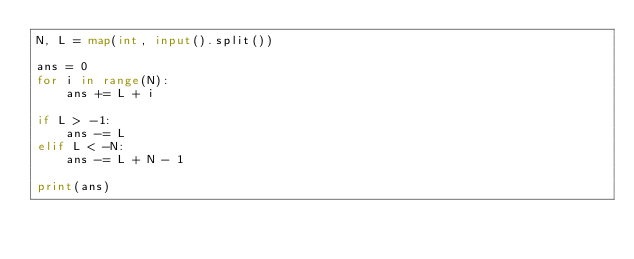<code> <loc_0><loc_0><loc_500><loc_500><_Python_>N, L = map(int, input().split())

ans = 0
for i in range(N):
    ans += L + i

if L > -1:
    ans -= L
elif L < -N:
    ans -= L + N - 1

print(ans)
</code> 